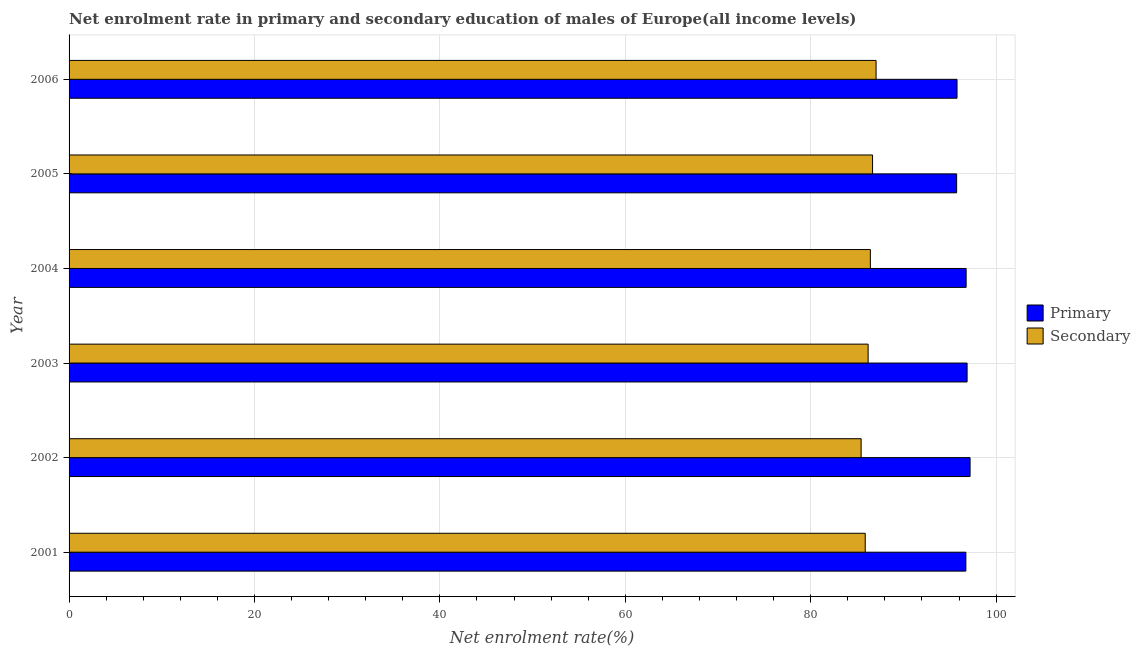How many groups of bars are there?
Give a very brief answer. 6. What is the enrollment rate in secondary education in 2001?
Your response must be concise. 85.88. Across all years, what is the maximum enrollment rate in secondary education?
Ensure brevity in your answer.  87.05. Across all years, what is the minimum enrollment rate in primary education?
Offer a terse response. 95.74. In which year was the enrollment rate in secondary education maximum?
Keep it short and to the point. 2006. What is the total enrollment rate in secondary education in the graph?
Keep it short and to the point. 517.66. What is the difference between the enrollment rate in primary education in 2002 and that in 2003?
Offer a terse response. 0.32. What is the difference between the enrollment rate in primary education in 2006 and the enrollment rate in secondary education in 2003?
Make the answer very short. 9.59. What is the average enrollment rate in secondary education per year?
Your answer should be very brief. 86.28. In the year 2004, what is the difference between the enrollment rate in primary education and enrollment rate in secondary education?
Your response must be concise. 10.33. In how many years, is the enrollment rate in secondary education greater than 68 %?
Your answer should be compact. 6. Is the enrollment rate in secondary education in 2003 less than that in 2004?
Ensure brevity in your answer.  Yes. What is the difference between the highest and the second highest enrollment rate in secondary education?
Your answer should be very brief. 0.38. What is the difference between the highest and the lowest enrollment rate in primary education?
Provide a short and direct response. 1.45. What does the 2nd bar from the top in 2002 represents?
Your answer should be very brief. Primary. What does the 1st bar from the bottom in 2003 represents?
Ensure brevity in your answer.  Primary. How many bars are there?
Your response must be concise. 12. Are all the bars in the graph horizontal?
Offer a very short reply. Yes. How many years are there in the graph?
Give a very brief answer. 6. Are the values on the major ticks of X-axis written in scientific E-notation?
Provide a short and direct response. No. Does the graph contain any zero values?
Provide a succinct answer. No. Does the graph contain grids?
Your answer should be very brief. Yes. Where does the legend appear in the graph?
Offer a very short reply. Center right. What is the title of the graph?
Offer a terse response. Net enrolment rate in primary and secondary education of males of Europe(all income levels). Does "From human activities" appear as one of the legend labels in the graph?
Offer a terse response. No. What is the label or title of the X-axis?
Your response must be concise. Net enrolment rate(%). What is the Net enrolment rate(%) in Primary in 2001?
Your answer should be very brief. 96.74. What is the Net enrolment rate(%) of Secondary in 2001?
Offer a very short reply. 85.88. What is the Net enrolment rate(%) in Primary in 2002?
Offer a very short reply. 97.19. What is the Net enrolment rate(%) in Secondary in 2002?
Give a very brief answer. 85.44. What is the Net enrolment rate(%) in Primary in 2003?
Give a very brief answer. 96.87. What is the Net enrolment rate(%) of Secondary in 2003?
Provide a short and direct response. 86.19. What is the Net enrolment rate(%) in Primary in 2004?
Your answer should be very brief. 96.76. What is the Net enrolment rate(%) in Secondary in 2004?
Offer a very short reply. 86.43. What is the Net enrolment rate(%) in Primary in 2005?
Give a very brief answer. 95.74. What is the Net enrolment rate(%) of Secondary in 2005?
Your answer should be very brief. 86.67. What is the Net enrolment rate(%) in Primary in 2006?
Your answer should be very brief. 95.78. What is the Net enrolment rate(%) of Secondary in 2006?
Your answer should be compact. 87.05. Across all years, what is the maximum Net enrolment rate(%) in Primary?
Offer a terse response. 97.19. Across all years, what is the maximum Net enrolment rate(%) of Secondary?
Keep it short and to the point. 87.05. Across all years, what is the minimum Net enrolment rate(%) of Primary?
Offer a terse response. 95.74. Across all years, what is the minimum Net enrolment rate(%) of Secondary?
Keep it short and to the point. 85.44. What is the total Net enrolment rate(%) in Primary in the graph?
Provide a succinct answer. 579.07. What is the total Net enrolment rate(%) in Secondary in the graph?
Your answer should be compact. 517.66. What is the difference between the Net enrolment rate(%) of Primary in 2001 and that in 2002?
Your answer should be very brief. -0.45. What is the difference between the Net enrolment rate(%) of Secondary in 2001 and that in 2002?
Make the answer very short. 0.44. What is the difference between the Net enrolment rate(%) of Primary in 2001 and that in 2003?
Your answer should be compact. -0.13. What is the difference between the Net enrolment rate(%) in Secondary in 2001 and that in 2003?
Offer a terse response. -0.31. What is the difference between the Net enrolment rate(%) in Primary in 2001 and that in 2004?
Keep it short and to the point. -0.03. What is the difference between the Net enrolment rate(%) in Secondary in 2001 and that in 2004?
Your answer should be compact. -0.55. What is the difference between the Net enrolment rate(%) of Secondary in 2001 and that in 2005?
Provide a succinct answer. -0.79. What is the difference between the Net enrolment rate(%) of Primary in 2001 and that in 2006?
Make the answer very short. 0.95. What is the difference between the Net enrolment rate(%) of Secondary in 2001 and that in 2006?
Offer a very short reply. -1.17. What is the difference between the Net enrolment rate(%) in Primary in 2002 and that in 2003?
Your answer should be very brief. 0.32. What is the difference between the Net enrolment rate(%) of Secondary in 2002 and that in 2003?
Provide a succinct answer. -0.75. What is the difference between the Net enrolment rate(%) in Primary in 2002 and that in 2004?
Make the answer very short. 0.43. What is the difference between the Net enrolment rate(%) of Secondary in 2002 and that in 2004?
Keep it short and to the point. -1. What is the difference between the Net enrolment rate(%) in Primary in 2002 and that in 2005?
Offer a terse response. 1.45. What is the difference between the Net enrolment rate(%) in Secondary in 2002 and that in 2005?
Provide a succinct answer. -1.23. What is the difference between the Net enrolment rate(%) of Primary in 2002 and that in 2006?
Offer a very short reply. 1.41. What is the difference between the Net enrolment rate(%) of Secondary in 2002 and that in 2006?
Provide a short and direct response. -1.61. What is the difference between the Net enrolment rate(%) of Primary in 2003 and that in 2004?
Provide a short and direct response. 0.1. What is the difference between the Net enrolment rate(%) in Secondary in 2003 and that in 2004?
Your response must be concise. -0.24. What is the difference between the Net enrolment rate(%) of Primary in 2003 and that in 2005?
Make the answer very short. 1.13. What is the difference between the Net enrolment rate(%) in Secondary in 2003 and that in 2005?
Provide a short and direct response. -0.48. What is the difference between the Net enrolment rate(%) in Primary in 2003 and that in 2006?
Keep it short and to the point. 1.09. What is the difference between the Net enrolment rate(%) in Secondary in 2003 and that in 2006?
Your response must be concise. -0.86. What is the difference between the Net enrolment rate(%) in Secondary in 2004 and that in 2005?
Your answer should be compact. -0.24. What is the difference between the Net enrolment rate(%) in Primary in 2004 and that in 2006?
Your answer should be compact. 0.98. What is the difference between the Net enrolment rate(%) of Secondary in 2004 and that in 2006?
Make the answer very short. -0.62. What is the difference between the Net enrolment rate(%) of Primary in 2005 and that in 2006?
Your response must be concise. -0.04. What is the difference between the Net enrolment rate(%) of Secondary in 2005 and that in 2006?
Your response must be concise. -0.38. What is the difference between the Net enrolment rate(%) in Primary in 2001 and the Net enrolment rate(%) in Secondary in 2002?
Keep it short and to the point. 11.3. What is the difference between the Net enrolment rate(%) of Primary in 2001 and the Net enrolment rate(%) of Secondary in 2003?
Your response must be concise. 10.54. What is the difference between the Net enrolment rate(%) of Primary in 2001 and the Net enrolment rate(%) of Secondary in 2004?
Provide a succinct answer. 10.3. What is the difference between the Net enrolment rate(%) of Primary in 2001 and the Net enrolment rate(%) of Secondary in 2005?
Keep it short and to the point. 10.06. What is the difference between the Net enrolment rate(%) of Primary in 2001 and the Net enrolment rate(%) of Secondary in 2006?
Make the answer very short. 9.69. What is the difference between the Net enrolment rate(%) in Primary in 2002 and the Net enrolment rate(%) in Secondary in 2003?
Your answer should be compact. 11. What is the difference between the Net enrolment rate(%) of Primary in 2002 and the Net enrolment rate(%) of Secondary in 2004?
Your answer should be very brief. 10.76. What is the difference between the Net enrolment rate(%) in Primary in 2002 and the Net enrolment rate(%) in Secondary in 2005?
Offer a terse response. 10.52. What is the difference between the Net enrolment rate(%) in Primary in 2002 and the Net enrolment rate(%) in Secondary in 2006?
Ensure brevity in your answer.  10.14. What is the difference between the Net enrolment rate(%) in Primary in 2003 and the Net enrolment rate(%) in Secondary in 2004?
Your answer should be very brief. 10.43. What is the difference between the Net enrolment rate(%) of Primary in 2003 and the Net enrolment rate(%) of Secondary in 2005?
Offer a terse response. 10.2. What is the difference between the Net enrolment rate(%) of Primary in 2003 and the Net enrolment rate(%) of Secondary in 2006?
Give a very brief answer. 9.82. What is the difference between the Net enrolment rate(%) of Primary in 2004 and the Net enrolment rate(%) of Secondary in 2005?
Keep it short and to the point. 10.09. What is the difference between the Net enrolment rate(%) in Primary in 2004 and the Net enrolment rate(%) in Secondary in 2006?
Your answer should be compact. 9.72. What is the difference between the Net enrolment rate(%) in Primary in 2005 and the Net enrolment rate(%) in Secondary in 2006?
Offer a terse response. 8.69. What is the average Net enrolment rate(%) in Primary per year?
Provide a short and direct response. 96.51. What is the average Net enrolment rate(%) of Secondary per year?
Offer a terse response. 86.28. In the year 2001, what is the difference between the Net enrolment rate(%) of Primary and Net enrolment rate(%) of Secondary?
Ensure brevity in your answer.  10.86. In the year 2002, what is the difference between the Net enrolment rate(%) of Primary and Net enrolment rate(%) of Secondary?
Provide a short and direct response. 11.75. In the year 2003, what is the difference between the Net enrolment rate(%) of Primary and Net enrolment rate(%) of Secondary?
Your response must be concise. 10.68. In the year 2004, what is the difference between the Net enrolment rate(%) of Primary and Net enrolment rate(%) of Secondary?
Offer a very short reply. 10.33. In the year 2005, what is the difference between the Net enrolment rate(%) of Primary and Net enrolment rate(%) of Secondary?
Your response must be concise. 9.07. In the year 2006, what is the difference between the Net enrolment rate(%) of Primary and Net enrolment rate(%) of Secondary?
Offer a terse response. 8.73. What is the ratio of the Net enrolment rate(%) in Primary in 2001 to that in 2002?
Your response must be concise. 1. What is the ratio of the Net enrolment rate(%) in Primary in 2001 to that in 2004?
Offer a terse response. 1. What is the ratio of the Net enrolment rate(%) of Primary in 2001 to that in 2005?
Ensure brevity in your answer.  1.01. What is the ratio of the Net enrolment rate(%) of Secondary in 2001 to that in 2005?
Provide a succinct answer. 0.99. What is the ratio of the Net enrolment rate(%) of Primary in 2001 to that in 2006?
Provide a short and direct response. 1.01. What is the ratio of the Net enrolment rate(%) of Secondary in 2001 to that in 2006?
Provide a short and direct response. 0.99. What is the ratio of the Net enrolment rate(%) in Primary in 2002 to that in 2003?
Give a very brief answer. 1. What is the ratio of the Net enrolment rate(%) of Secondary in 2002 to that in 2003?
Offer a terse response. 0.99. What is the ratio of the Net enrolment rate(%) of Primary in 2002 to that in 2005?
Ensure brevity in your answer.  1.02. What is the ratio of the Net enrolment rate(%) of Secondary in 2002 to that in 2005?
Ensure brevity in your answer.  0.99. What is the ratio of the Net enrolment rate(%) in Primary in 2002 to that in 2006?
Provide a short and direct response. 1.01. What is the ratio of the Net enrolment rate(%) in Secondary in 2002 to that in 2006?
Your response must be concise. 0.98. What is the ratio of the Net enrolment rate(%) in Primary in 2003 to that in 2005?
Your response must be concise. 1.01. What is the ratio of the Net enrolment rate(%) in Primary in 2003 to that in 2006?
Ensure brevity in your answer.  1.01. What is the ratio of the Net enrolment rate(%) in Secondary in 2003 to that in 2006?
Your answer should be compact. 0.99. What is the ratio of the Net enrolment rate(%) of Primary in 2004 to that in 2005?
Make the answer very short. 1.01. What is the ratio of the Net enrolment rate(%) in Primary in 2004 to that in 2006?
Provide a succinct answer. 1.01. What is the ratio of the Net enrolment rate(%) of Secondary in 2004 to that in 2006?
Your answer should be compact. 0.99. What is the ratio of the Net enrolment rate(%) in Primary in 2005 to that in 2006?
Your answer should be very brief. 1. What is the difference between the highest and the second highest Net enrolment rate(%) in Primary?
Your response must be concise. 0.32. What is the difference between the highest and the second highest Net enrolment rate(%) in Secondary?
Offer a terse response. 0.38. What is the difference between the highest and the lowest Net enrolment rate(%) of Primary?
Your response must be concise. 1.45. What is the difference between the highest and the lowest Net enrolment rate(%) of Secondary?
Your answer should be compact. 1.61. 